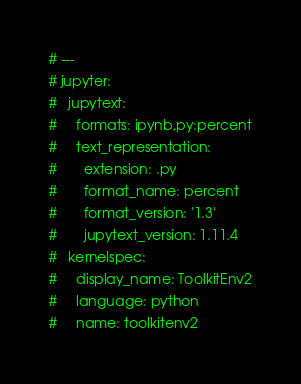Convert code to text. <code><loc_0><loc_0><loc_500><loc_500><_Python_># ---
# jupyter:
#   jupytext:
#     formats: ipynb,py:percent
#     text_representation:
#       extension: .py
#       format_name: percent
#       format_version: '1.3'
#       jupytext_version: 1.11.4
#   kernelspec:
#     display_name: ToolkitEnv2
#     language: python
#     name: toolkitenv2</code> 